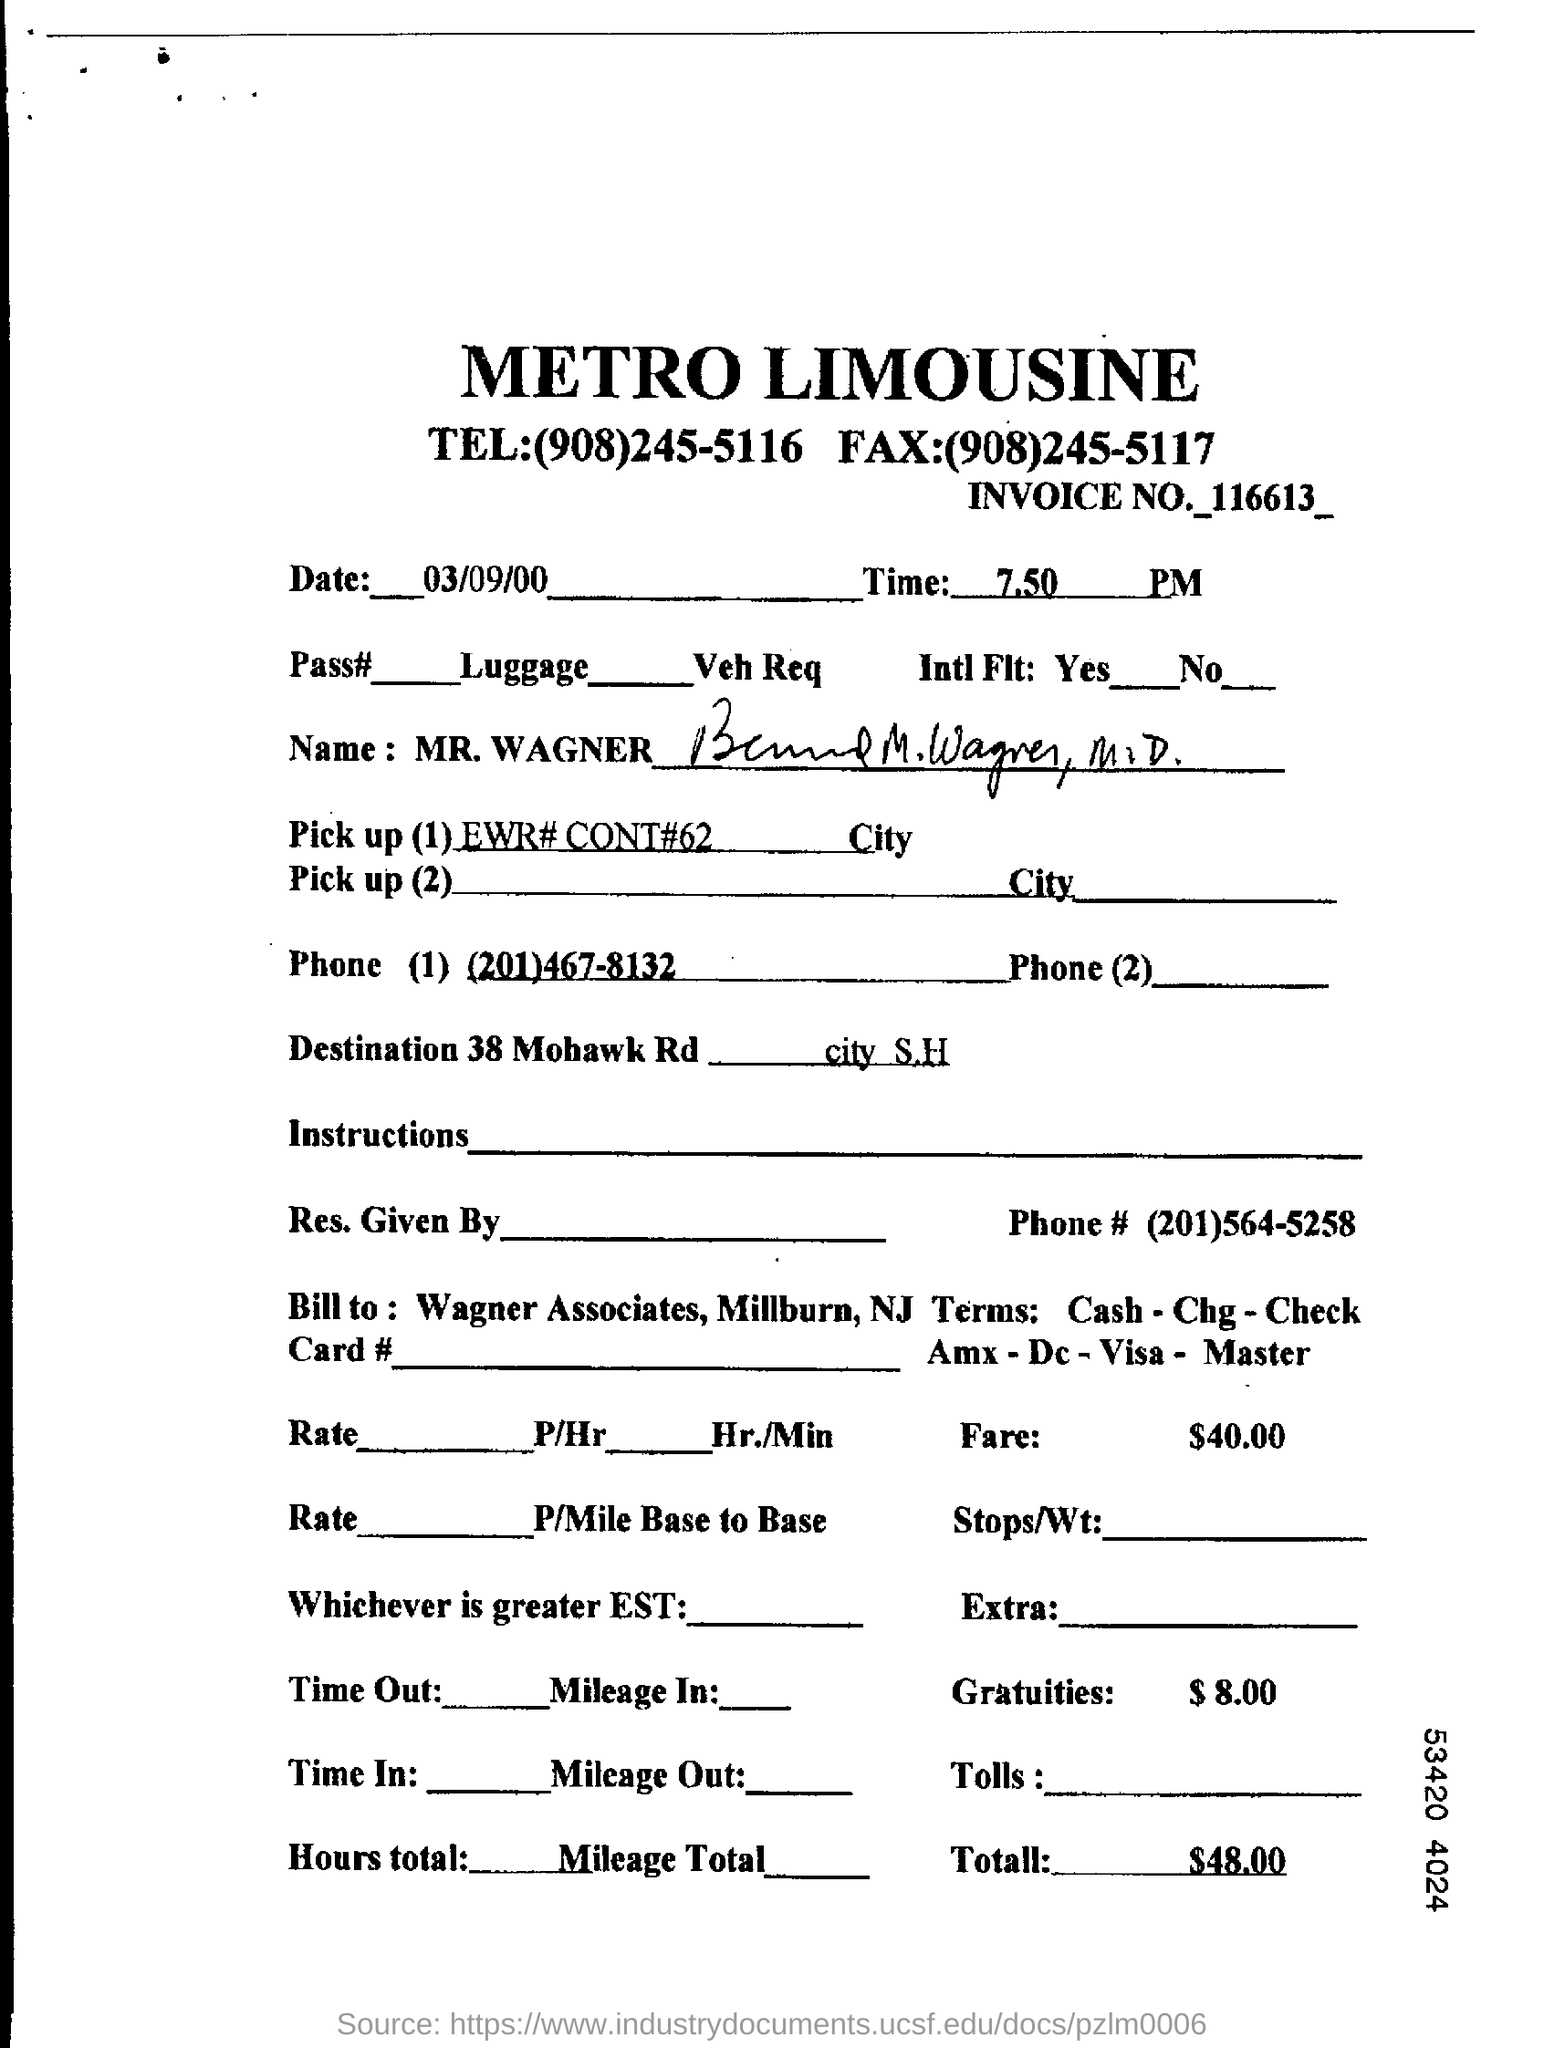Which company or firm's name is written at the top?
Offer a terse response. METRO LIMOUSINE. What is the Invoice Number ?
Your response must be concise. 116613. What is the telephone  Number for Metro limousine ?
Your answer should be very brief. (908)245-5116. What is the Fax Number for metro limousine ?
Offer a terse response. (908)245-5117. What is the date mentioned in the top of the document ?
Your response must be concise. 03/09/00. What time mentioned in the top of the Document ?
Provide a succinct answer. 7.50 PM. What is the Fare Amount ?
Your answer should be compact. $40.00. What is the Total amount ?
Your answer should be very brief. $48.00. 